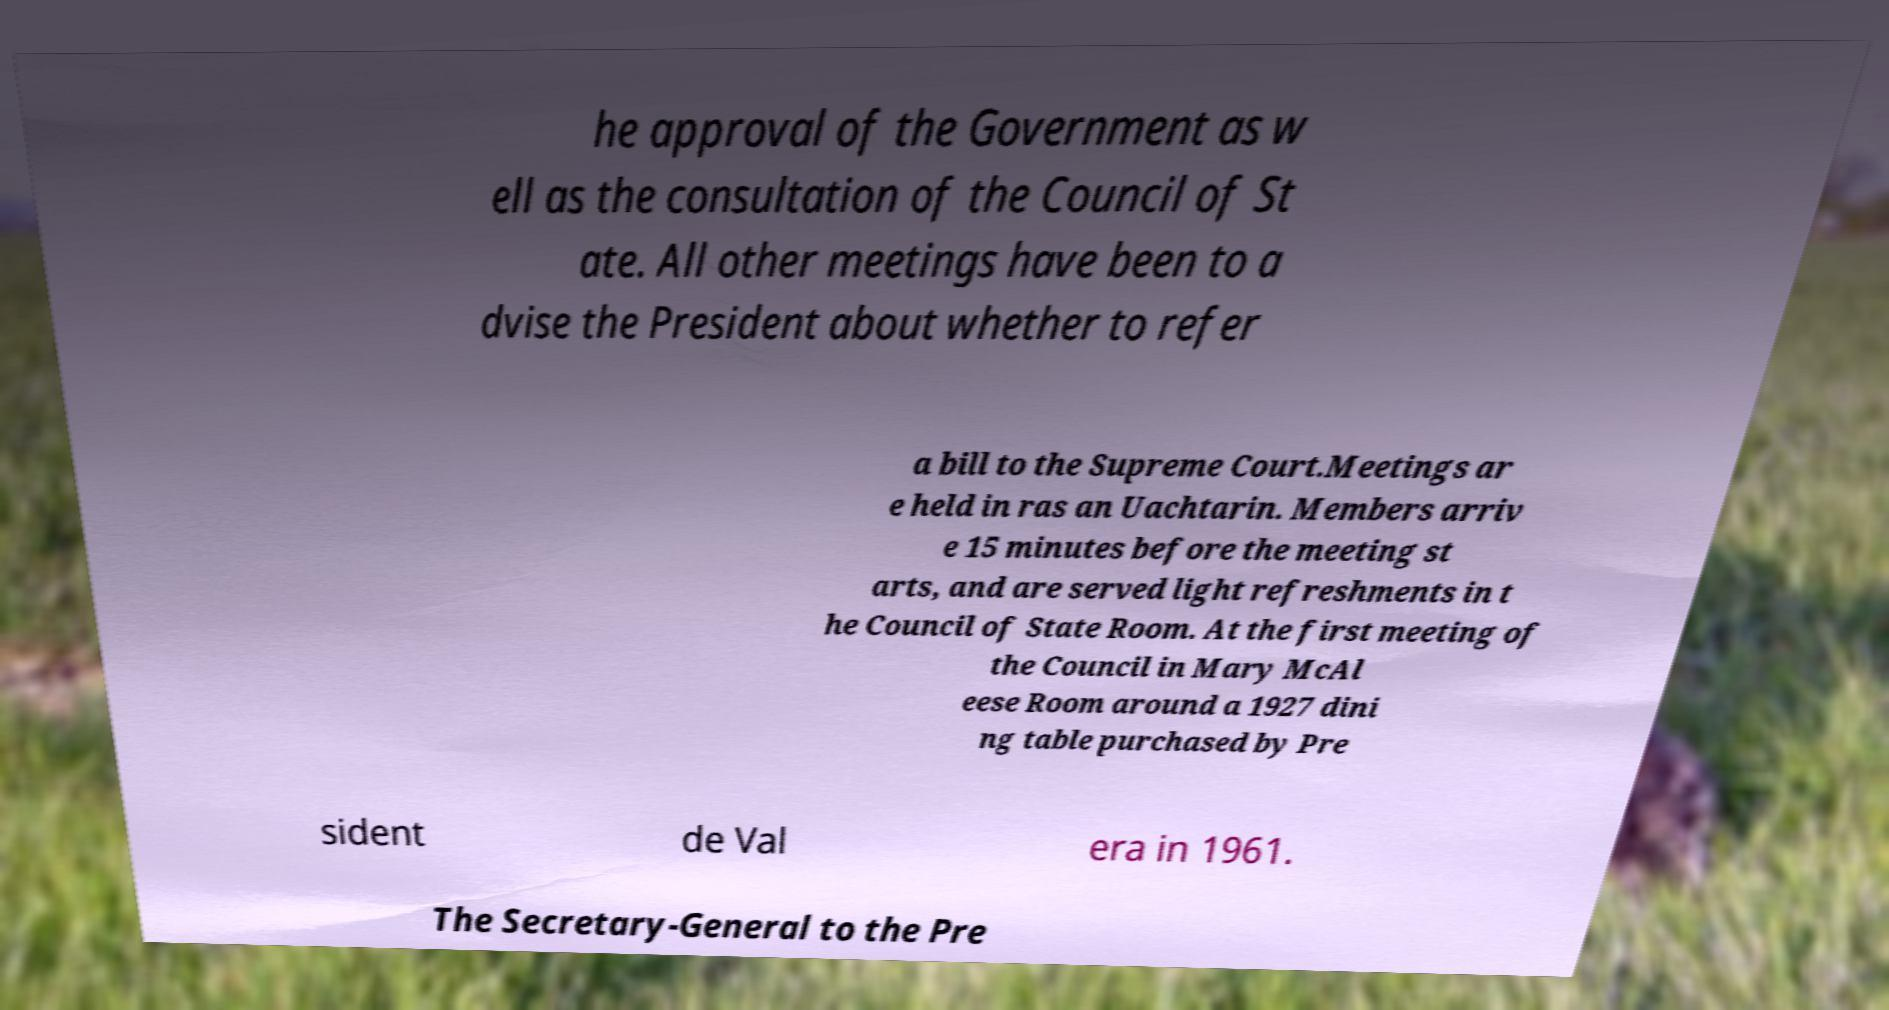Please identify and transcribe the text found in this image. he approval of the Government as w ell as the consultation of the Council of St ate. All other meetings have been to a dvise the President about whether to refer a bill to the Supreme Court.Meetings ar e held in ras an Uachtarin. Members arriv e 15 minutes before the meeting st arts, and are served light refreshments in t he Council of State Room. At the first meeting of the Council in Mary McAl eese Room around a 1927 dini ng table purchased by Pre sident de Val era in 1961. The Secretary-General to the Pre 